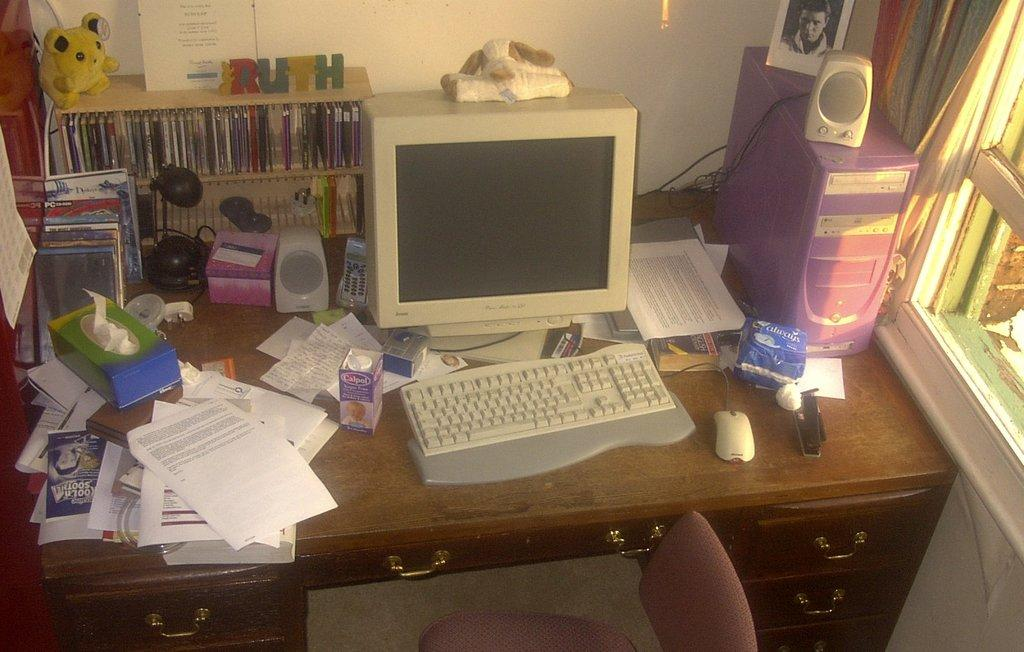<image>
Render a clear and concise summary of the photo. A desk is littered with a myriad of different items, including a box of Kleenex, and the name Ruth is visible in wooden letters on a shelf. 